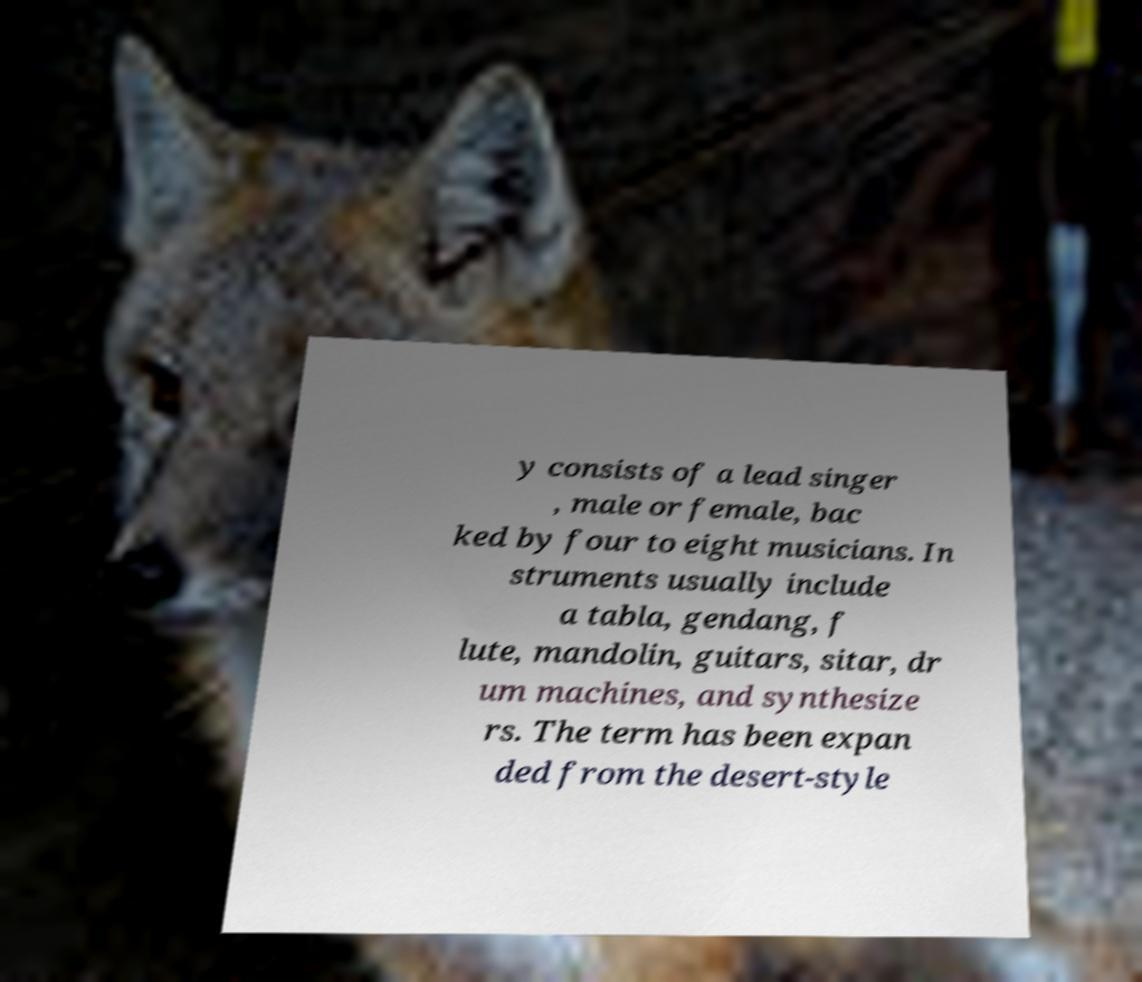Please identify and transcribe the text found in this image. y consists of a lead singer , male or female, bac ked by four to eight musicians. In struments usually include a tabla, gendang, f lute, mandolin, guitars, sitar, dr um machines, and synthesize rs. The term has been expan ded from the desert-style 